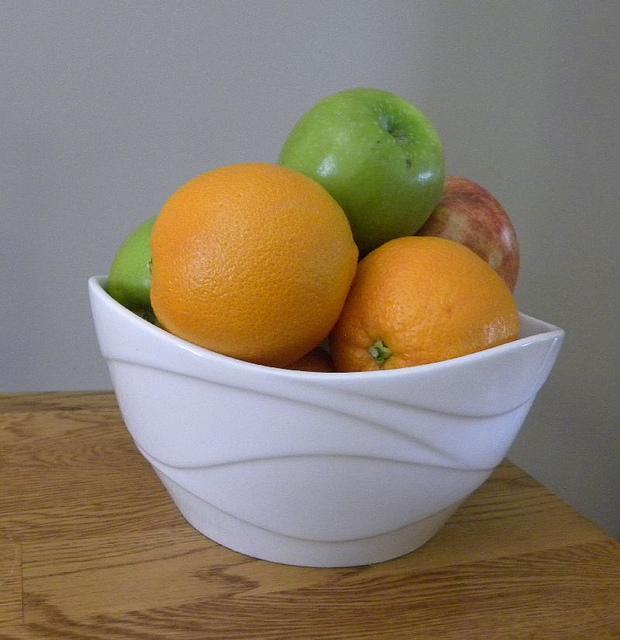What color skin does the tartest fruit seen here have?
Indicate the correct response and explain using: 'Answer: answer
Rationale: rationale.'
Options: Green, yellow, orange, red. Answer: green.
Rationale: Green apples are more tart. 